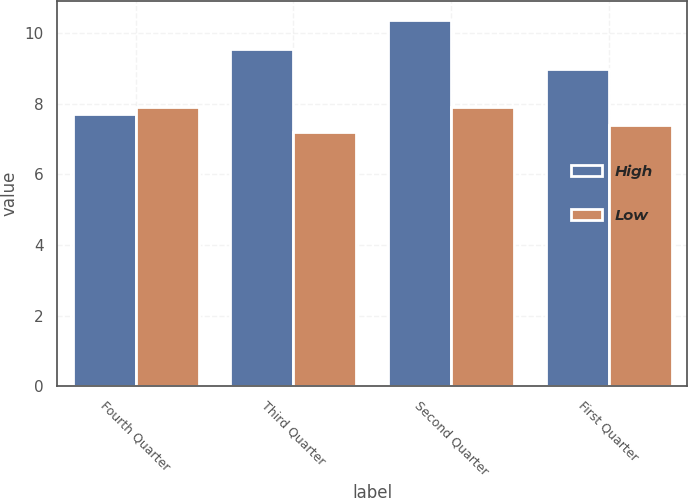<chart> <loc_0><loc_0><loc_500><loc_500><stacked_bar_chart><ecel><fcel>Fourth Quarter<fcel>Third Quarter<fcel>Second Quarter<fcel>First Quarter<nl><fcel>High<fcel>7.7<fcel>9.57<fcel>10.39<fcel>8.98<nl><fcel>Low<fcel>7.9<fcel>7.21<fcel>7.9<fcel>7.4<nl></chart> 